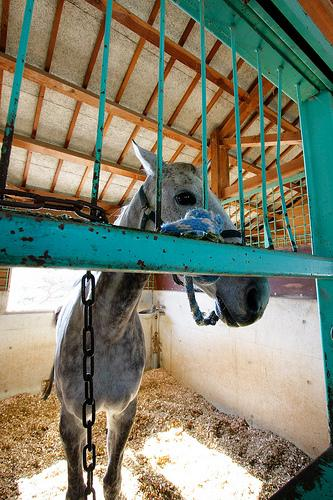Describe the condition of the bars in the image and how they're connected to the horse. The metal bars are painted aqua, dented, and connected to the horse using a blue and white rope and a large interwoven chain. Provide a brief overview of the primary elements within the image. A large horse stands in a stall with sawdust floor, sunlight entering through a window, and the horse is tied to green metal bars with a blue rope. Use short phrases to describe important details seen in the image. Horse in stall, blue and white rope, green metal bars, wooden rafters, light from window, sawdust and wood chips on floor. Write a brief description of the image with key elements about the flooring. A horse stands in a stall with sawdust and wood chips on the floor, metal bars on the side wall, and light entering from a window. Mention the key visual aspects of the horse's environment in the image. Metal bars are painted aqua, wooden rafters on the ceiling, window letting light in, and a floor covered in wood chips and hay. Illustrate the details of the horse's facial features seen in the image. The horse has a closed mouth, a visible eye, an ear, a nostril, and the nose is showing with the halter worn on its head. State the main subject of the image and its surroundings with an element of their interaction. A horse in the stall, standing amid sawdust, is tethered to green metal bars with a blue and white rope, while light pours in from a window. In simple words, describe the main object in the image and its surroundings. A big horse is inside a stall with light coming in from the window, standing on a floor covered in sawdust, and tied with a blue rope to bars. Highlight the elements related to the horse's restraints in the image. Horse is tied to green metal bars using a blue and white rope, with a large chain wove in the fence, and a halter on its head. Describe the main animal in the image, its color, and what it's wearing. The horse is  white and brown, and is wearing a halter on its head, with a blue and white rope tying it to the metal bars. 